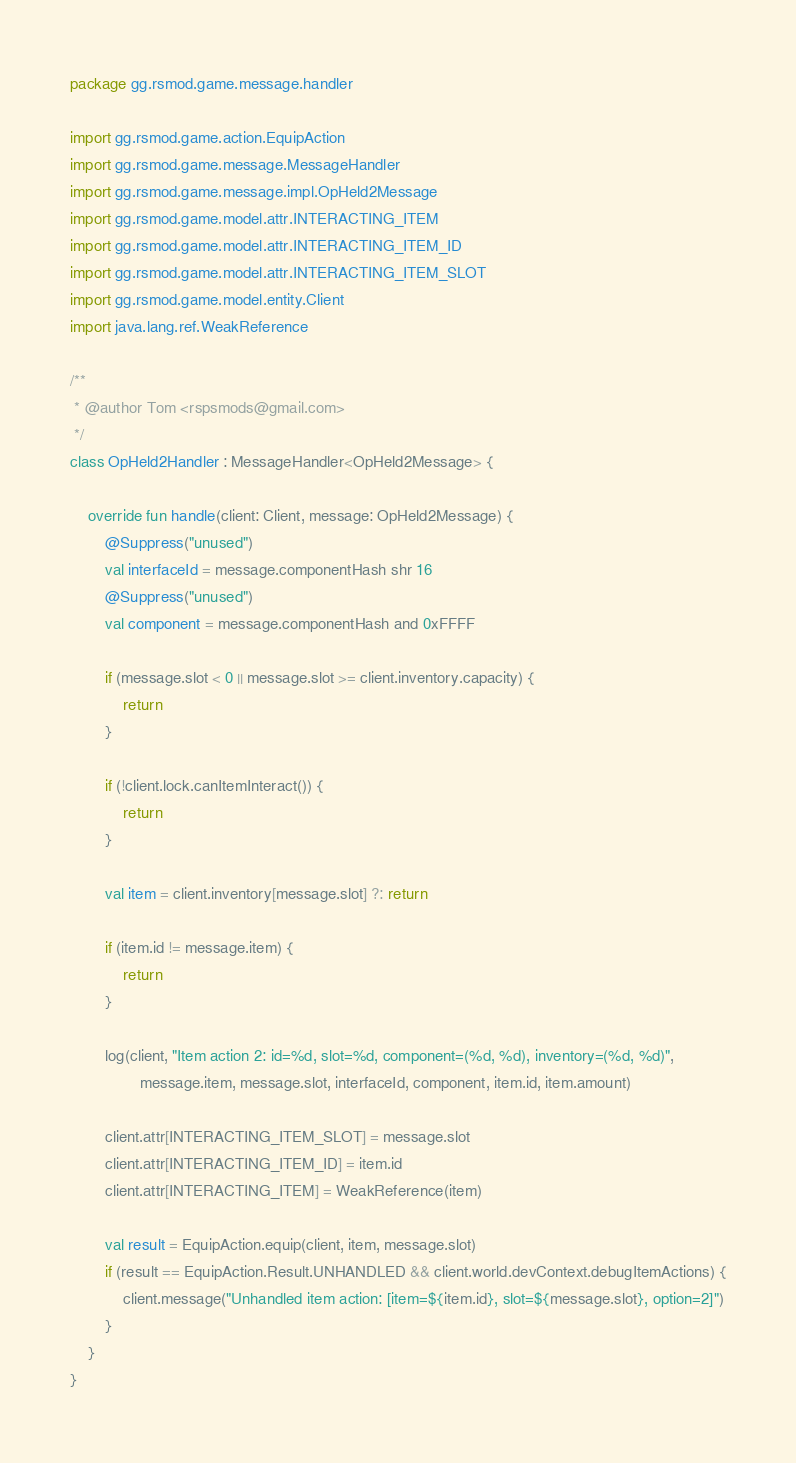Convert code to text. <code><loc_0><loc_0><loc_500><loc_500><_Kotlin_>package gg.rsmod.game.message.handler

import gg.rsmod.game.action.EquipAction
import gg.rsmod.game.message.MessageHandler
import gg.rsmod.game.message.impl.OpHeld2Message
import gg.rsmod.game.model.attr.INTERACTING_ITEM
import gg.rsmod.game.model.attr.INTERACTING_ITEM_ID
import gg.rsmod.game.model.attr.INTERACTING_ITEM_SLOT
import gg.rsmod.game.model.entity.Client
import java.lang.ref.WeakReference

/**
 * @author Tom <rspsmods@gmail.com>
 */
class OpHeld2Handler : MessageHandler<OpHeld2Message> {

    override fun handle(client: Client, message: OpHeld2Message) {
        @Suppress("unused")
        val interfaceId = message.componentHash shr 16
        @Suppress("unused")
        val component = message.componentHash and 0xFFFF

        if (message.slot < 0 || message.slot >= client.inventory.capacity) {
            return
        }

        if (!client.lock.canItemInteract()) {
            return
        }

        val item = client.inventory[message.slot] ?: return

        if (item.id != message.item) {
            return
        }

        log(client, "Item action 2: id=%d, slot=%d, component=(%d, %d), inventory=(%d, %d)",
                message.item, message.slot, interfaceId, component, item.id, item.amount)

        client.attr[INTERACTING_ITEM_SLOT] = message.slot
        client.attr[INTERACTING_ITEM_ID] = item.id
        client.attr[INTERACTING_ITEM] = WeakReference(item)

        val result = EquipAction.equip(client, item, message.slot)
        if (result == EquipAction.Result.UNHANDLED && client.world.devContext.debugItemActions) {
            client.message("Unhandled item action: [item=${item.id}, slot=${message.slot}, option=2]")
        }
    }
}</code> 